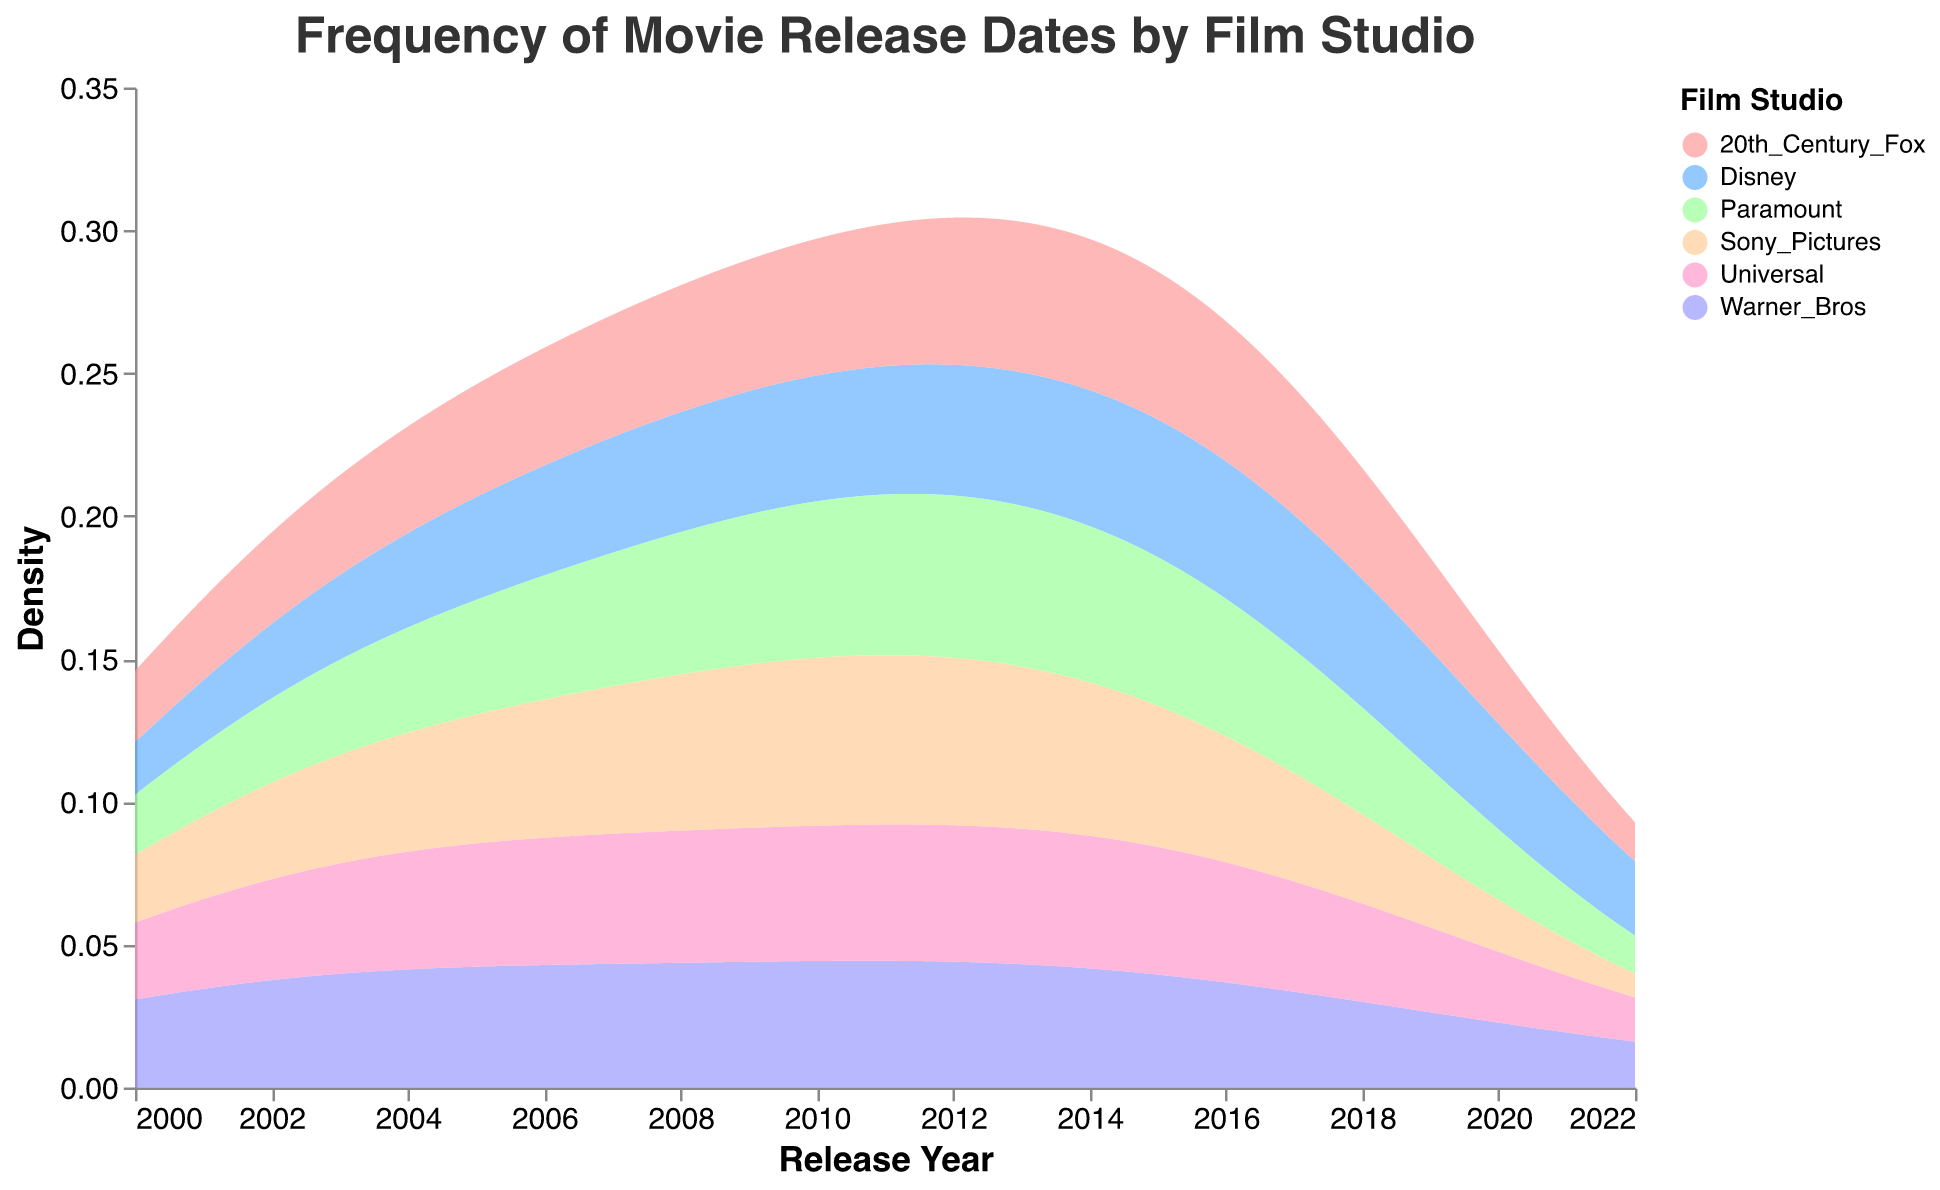What's the title of the figure? The title is displayed at the top of the figure and reads "Frequency of Movie Release Dates by Film Studio".
Answer: Frequency of Movie Release Dates by Film Studio What does the x-axis represent? The x-axis represents the release year of the movies, which is evident from the years labeled along the x-axis and the title "Release Year".
Answer: Release Year Which film studio has the highest density of releases in 2017? By visually inspecting the 2017 mark on the x-axis and looking at the corresponding peaks in the density curves, Disney has the highest density in that year.
Answer: Disney Which film studio has the widest range of release years? By observing the density plots spread along the x-axis, Warner Bros. has releases from 2000 to 2022, which is the widest range among the studios.
Answer: Warner Bros How does the density of movie releases for Paramount compare to Universal between 2010 and 2016? Between 2010 and 2016, both Paramount and Universal show similar densities with peaks around the same years, but the intensity slightly favors Universal as it has higher peaks within that timeframe.
Answer: Universal Are there periods where no movies were released by any of the film studios listed? By examining the density plots across all years, there are no points where all density curves drop to zero, indicating that movies were released by at least one film studio every year.
Answer: No Which film studio had a peak in movie releases around 2005? By looking at the density plot near the year 2005, both Warner Bros. and Sony Pictures have noticeable peaks around this year, but the peak is slightly higher for Sony Pictures.
Answer: Sony Pictures What are the top three years for Disney in terms of movie release density? By identifying the peaks in Disney's density plot, the top three years are 2017, 2016, and 2019.
Answer: 2017, 2016, and 2019 Which studio shows a density spike around 2010 and how can you tell? Both Disney and Universal show density spikes around 2010, which can be observed from the peaks in their density plots at the year 2010.
Answer: Disney and Universal How does the density of movie releases for 20th Century Fox change from 2010 to 2022? By inspecting the density plot for 20th Century Fox, the density mildly increases around 2013 and remains relatively steady up until 2018, and then there’s a noticeable drop in releases afterward.
Answer: Steady increase until 2018, then drops 